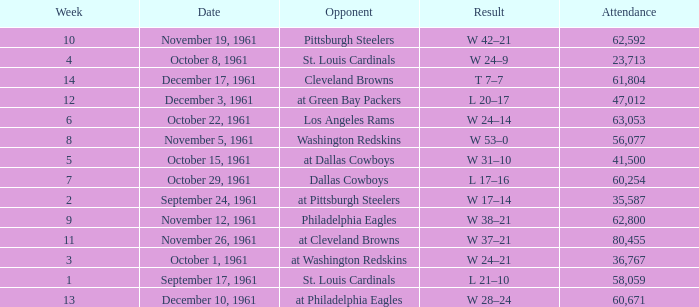What was the result on october 8, 1961? W 24–9. 